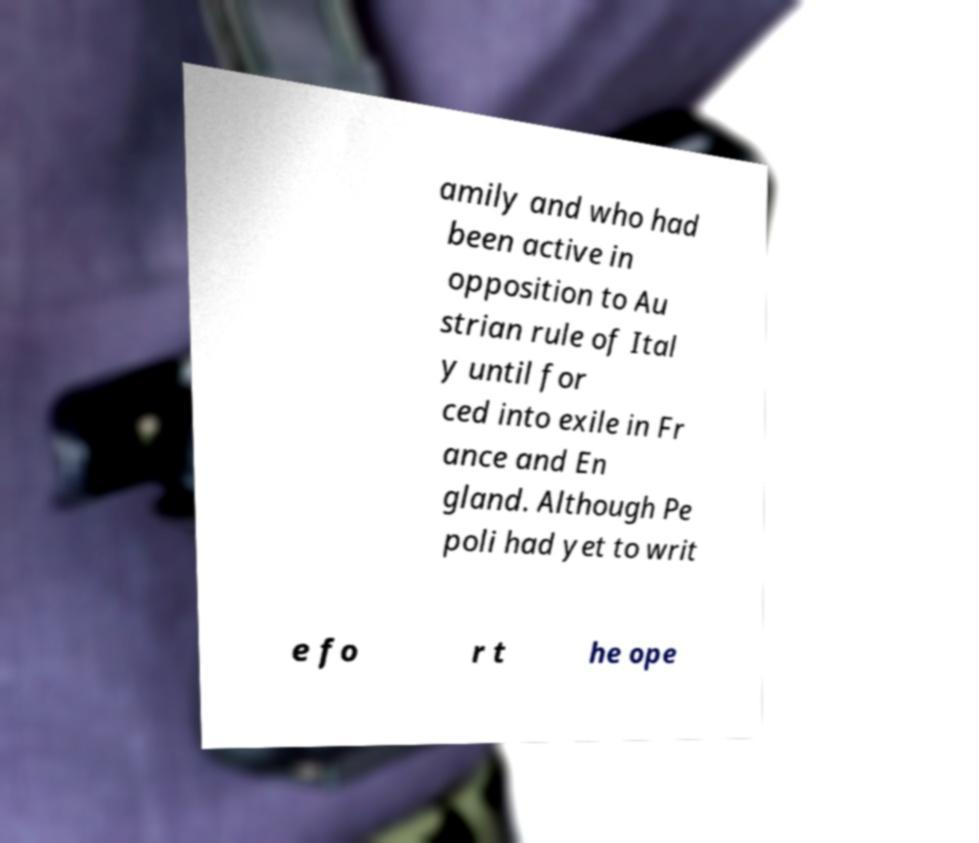Can you read and provide the text displayed in the image?This photo seems to have some interesting text. Can you extract and type it out for me? amily and who had been active in opposition to Au strian rule of Ital y until for ced into exile in Fr ance and En gland. Although Pe poli had yet to writ e fo r t he ope 